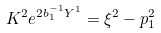Convert formula to latex. <formula><loc_0><loc_0><loc_500><loc_500>K ^ { 2 } e ^ { 2 b _ { 1 } ^ { - 1 } Y ^ { 1 } } = \xi ^ { 2 } - p _ { 1 } ^ { 2 }</formula> 